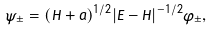Convert formula to latex. <formula><loc_0><loc_0><loc_500><loc_500>\psi _ { \pm } = ( H + a ) ^ { 1 / 2 } | E - H | ^ { - 1 / 2 } \varphi _ { \pm } ,</formula> 